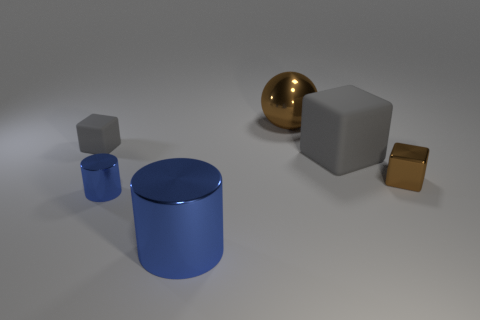Add 2 big brown balls. How many objects exist? 8 Subtract all cylinders. How many objects are left? 4 Subtract all tiny gray objects. Subtract all large gray things. How many objects are left? 4 Add 1 brown metallic things. How many brown metallic things are left? 3 Add 6 big objects. How many big objects exist? 9 Subtract 0 yellow spheres. How many objects are left? 6 